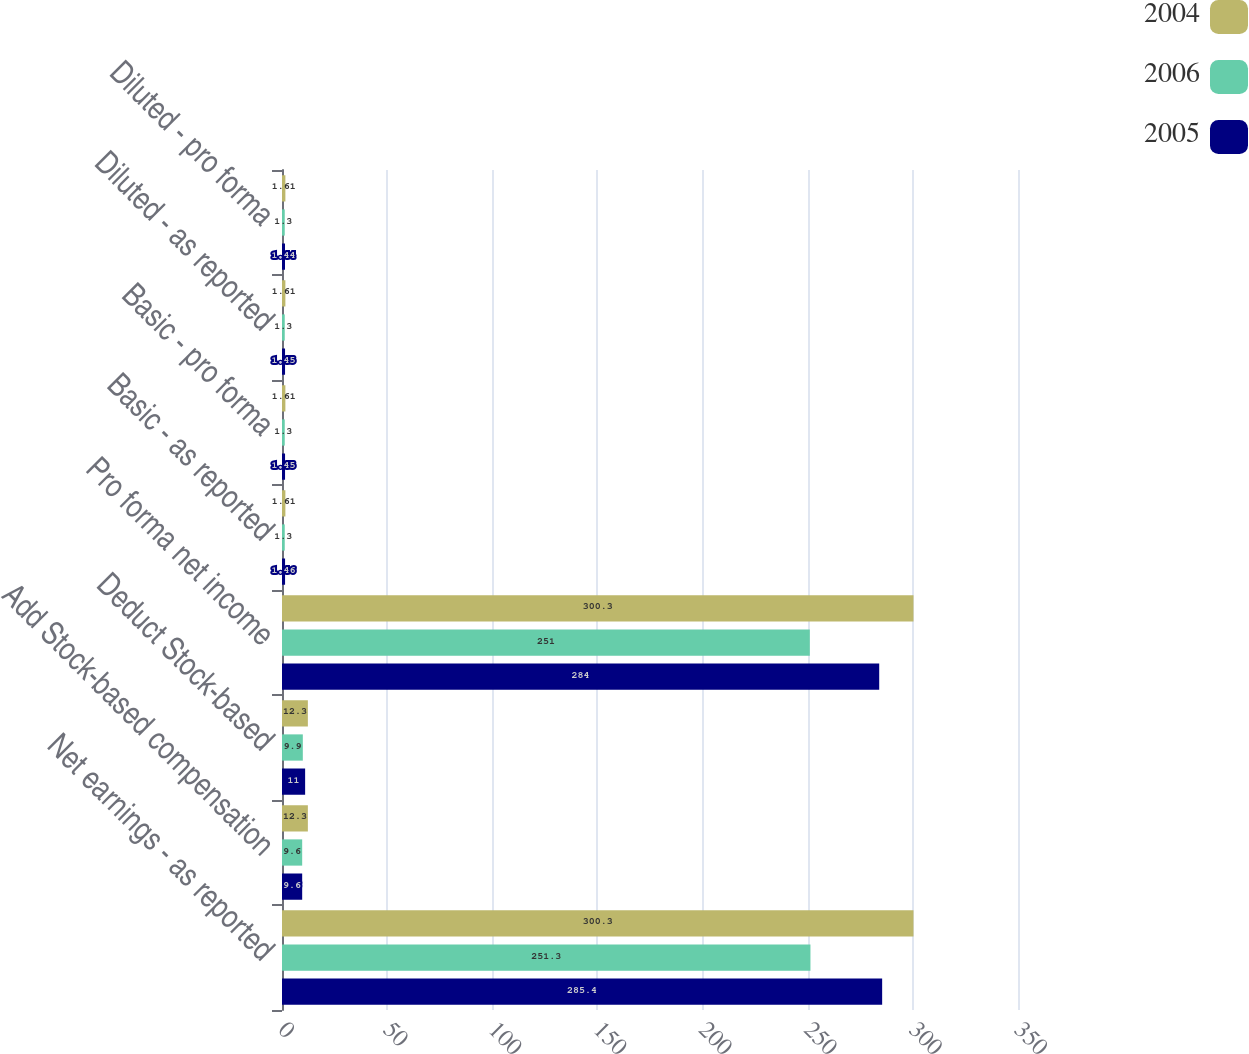Convert chart to OTSL. <chart><loc_0><loc_0><loc_500><loc_500><stacked_bar_chart><ecel><fcel>Net earnings - as reported<fcel>Add Stock-based compensation<fcel>Deduct Stock-based<fcel>Pro forma net income<fcel>Basic - as reported<fcel>Basic - pro forma<fcel>Diluted - as reported<fcel>Diluted - pro forma<nl><fcel>2004<fcel>300.3<fcel>12.3<fcel>12.3<fcel>300.3<fcel>1.61<fcel>1.61<fcel>1.61<fcel>1.61<nl><fcel>2006<fcel>251.3<fcel>9.6<fcel>9.9<fcel>251<fcel>1.3<fcel>1.3<fcel>1.3<fcel>1.3<nl><fcel>2005<fcel>285.4<fcel>9.6<fcel>11<fcel>284<fcel>1.46<fcel>1.45<fcel>1.45<fcel>1.44<nl></chart> 